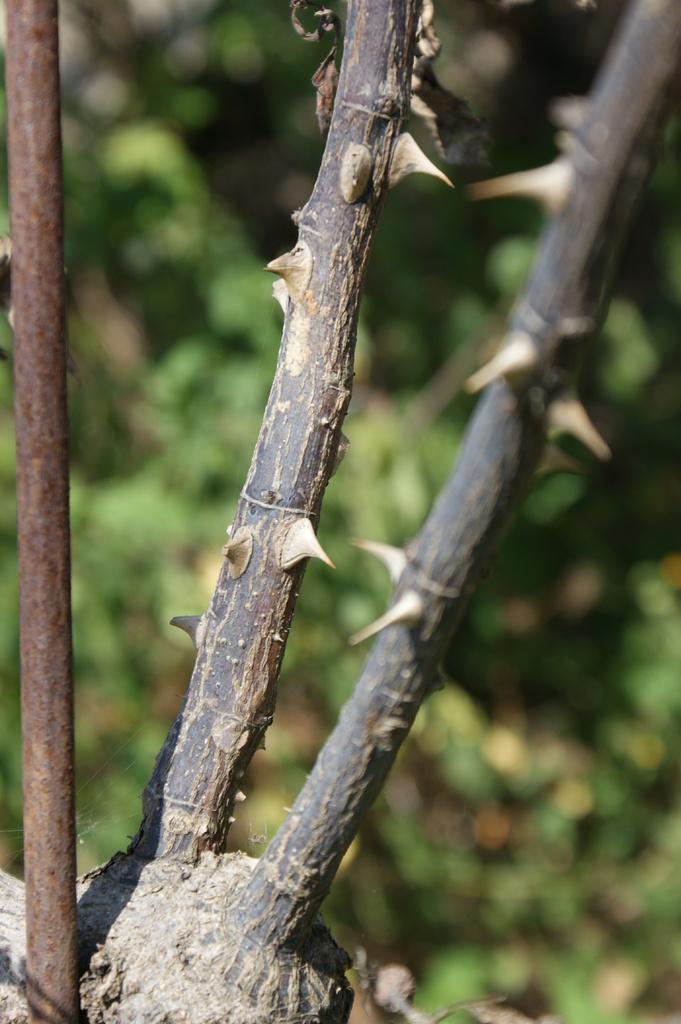Can you describe this image briefly? In this picture I can observe thorns to the stems. On the left side I can observe a pole. The background is blurred. 